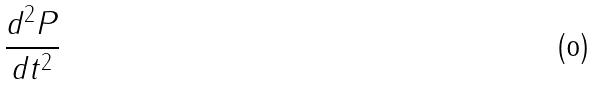<formula> <loc_0><loc_0><loc_500><loc_500>\frac { d ^ { 2 } P } { d t ^ { 2 } }</formula> 